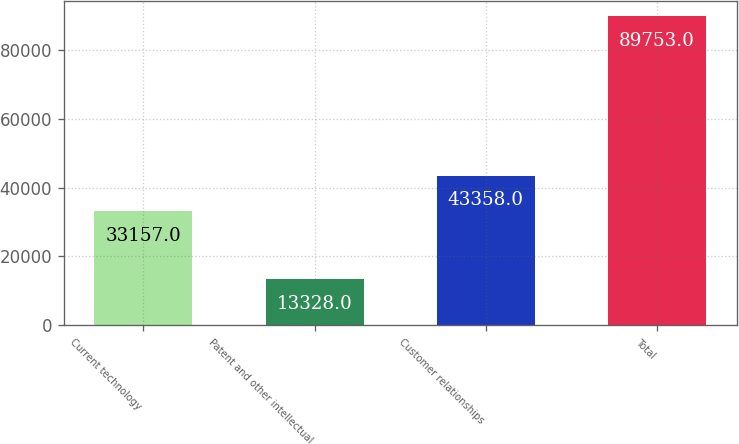Convert chart to OTSL. <chart><loc_0><loc_0><loc_500><loc_500><bar_chart><fcel>Current technology<fcel>Patent and other intellectual<fcel>Customer relationships<fcel>Total<nl><fcel>33157<fcel>13328<fcel>43358<fcel>89753<nl></chart> 